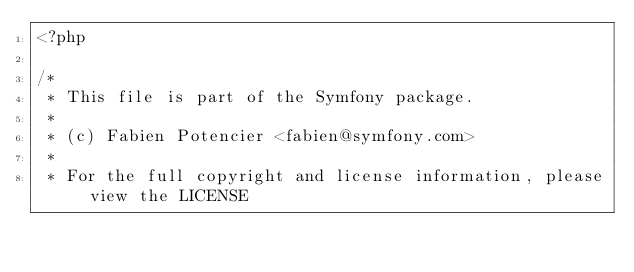<code> <loc_0><loc_0><loc_500><loc_500><_PHP_><?php

/*
 * This file is part of the Symfony package.
 *
 * (c) Fabien Potencier <fabien@symfony.com>
 *
 * For the full copyright and license information, please view the LICENSE</code> 